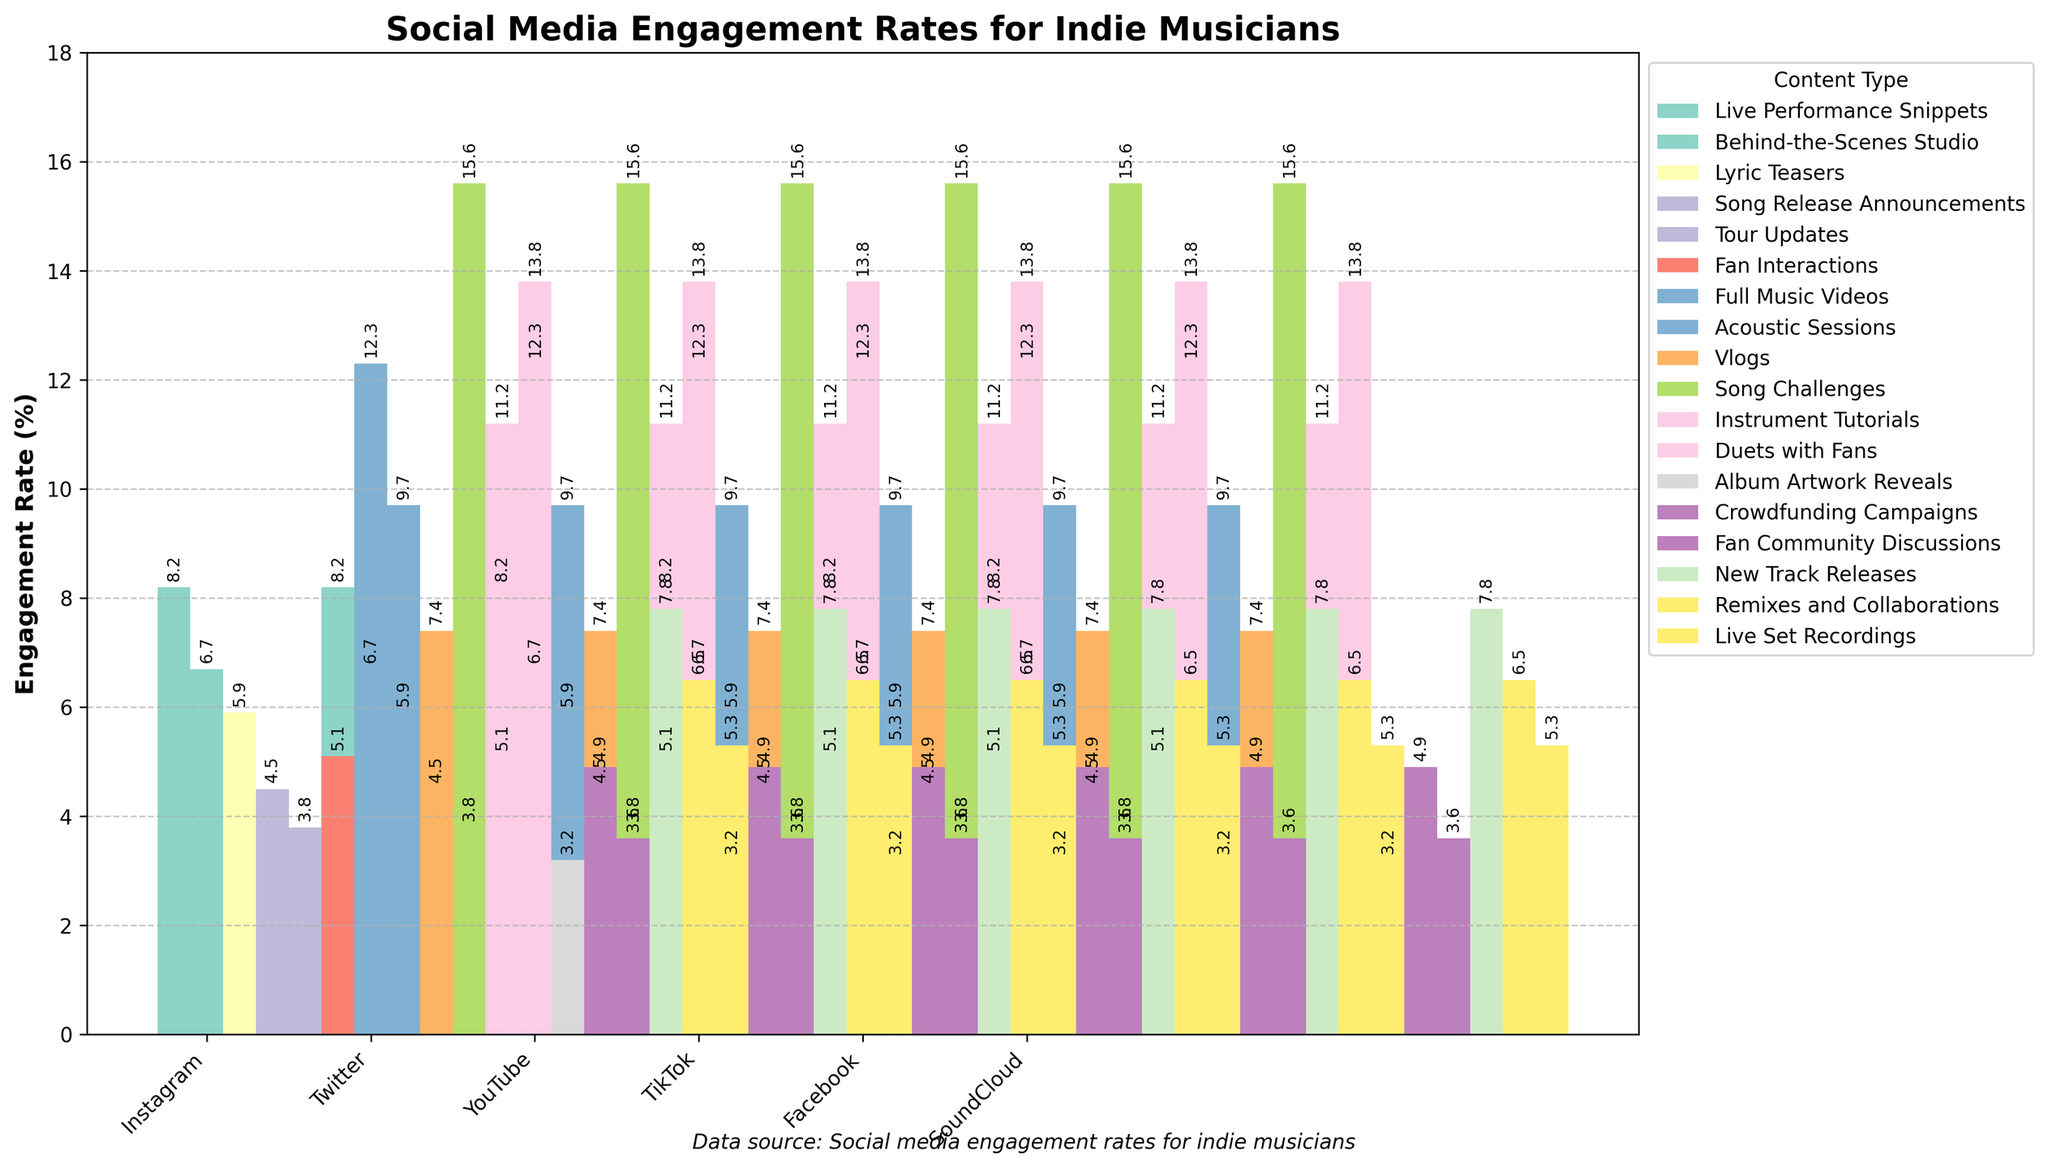Which platform has the highest engagement rate for Song Challenges? TikTok has the highest engagement rate for Song Challenges at 15.6%. To find this, look for the Song Challenges content type and compare engagement rates across different platforms, noting that TikTok has the highest value at 15.6%.
Answer: TikTok What content type has the highest engagement rate on YouTube? The content type with the highest engagement rate on YouTube is Full Music Videos at 12.3%. This can be seen by comparing the engagement rates of different content types on the YouTube section of the bar chart, where Full Music Videos have the tallest bar.
Answer: Full Music Videos Which type of content on Instagram has the lowest engagement rate? Lyric Teasers have the lowest engagement rate on Instagram at 5.9%. This information can be observed by comparing the different engagement rates for content types within the Instagram section of the bar chart, with Lyric Teasers having the shortest bar.
Answer: Lyric Teasers On average, which platform has the highest engagement rate? To determine the average engagement rate per platform, sum the engagement rates of each content type for a platform and then divide by the number of content types. TikTok has the highest average engagement rate: (15.6 + 11.2 + 13.8) / 3 = 13.53%.
Answer: TikTok By how much does the engagement rate for Vlogs on YouTube exceed that of Fan Community Discussions on Facebook? The engagement rate for Vlogs on YouTube is 7.4%, while for Fan Community Discussions on Facebook it's 3.6%. Subtract these values: 7.4% - 3.6% = 3.8%.
Answer: 3.8% Which two content types have similar engagement rates on SoundCloud? New Track Releases and Remixes and Collaborations on SoundCloud have similar engagement rates, with values of 7.8% and 6.5% respectively. To determine this, compare the engagement rates for different content types on SoundCloud and identify New Track Releases and Remixes and Collaborations as the two closest values.
Answer: New Track Releases and Remixes and Collaborations Compare the engagement rates for Fan Interactions on Twitter and Live Performance Snippets on Instagram. Which one is higher? The engagement rate for Fan Interactions on Twitter is 5.1%, and for Live Performance Snippets on Instagram, it is 8.2%. Observing these values, Live Performance Snippets on Instagram has a higher engagement rate.
Answer: Live Performance Snippets on Instagram What is the difference between the highest and lowest engagement rates across all platforms and content types? The highest engagement rate is TikTok's Song Challenges at 15.6%, and the lowest is Facebook's Album Artwork Reveals at 3.2%. Subtract the lowest rate from the highest: 15.6% - 3.2% = 12.4%.
Answer: 12.4% Which content type on Facebook exceeds the engagement rate of Acoustic Sessions on YouTube? Crowdfunding Campaigns on Facebook exceed the engagement rate of Acoustic Sessions on YouTube. Acoustic Sessions have a rate of 9.7%, and Crowdfunding Campaigns are at 4.9%, while no content type on Facebook surpasses the 9.7% rate. Hence, no content type on Facebook exceeds Acoustic Sessions.
Answer: None 